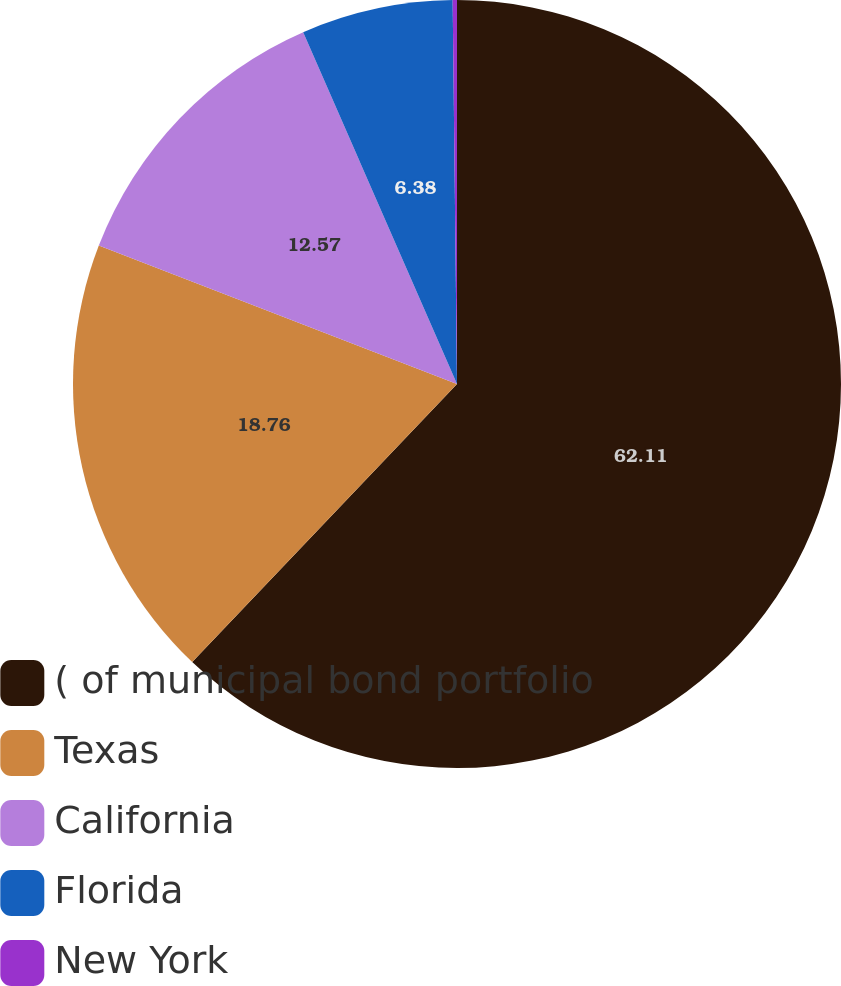Convert chart to OTSL. <chart><loc_0><loc_0><loc_500><loc_500><pie_chart><fcel>( of municipal bond portfolio<fcel>Texas<fcel>California<fcel>Florida<fcel>New York<nl><fcel>62.11%<fcel>18.76%<fcel>12.57%<fcel>6.38%<fcel>0.18%<nl></chart> 